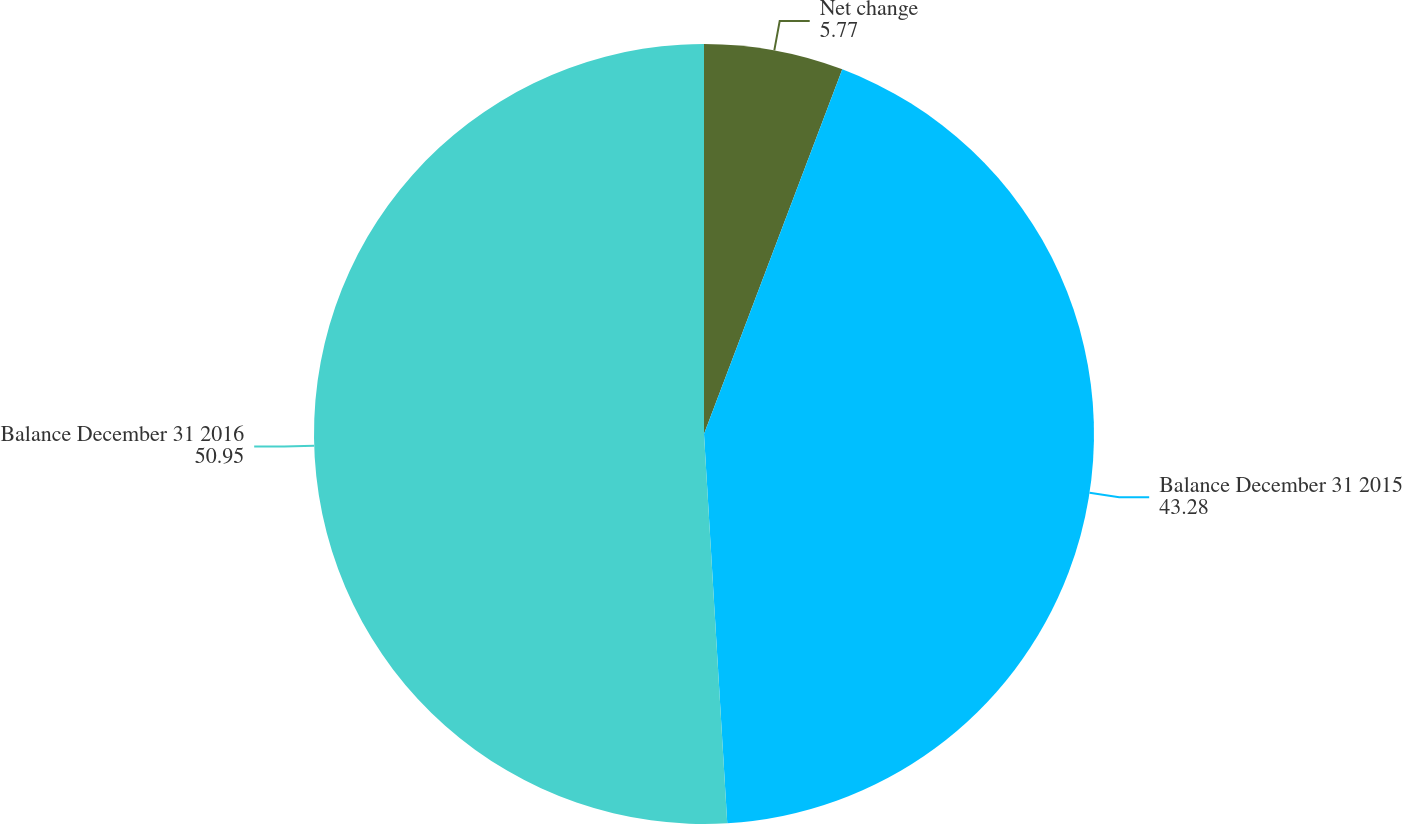<chart> <loc_0><loc_0><loc_500><loc_500><pie_chart><fcel>Net change<fcel>Balance December 31 2015<fcel>Balance December 31 2016<nl><fcel>5.77%<fcel>43.28%<fcel>50.95%<nl></chart> 